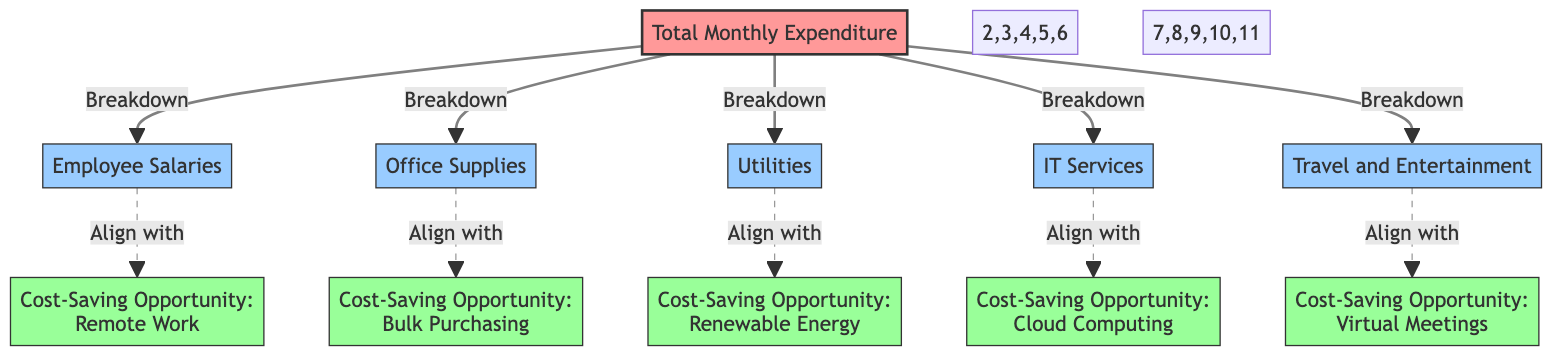What is the total node count in the diagram? The diagram has 11 nodes, including the total monthly expenditure node and the six categories of expenditure along with five cost-saving opportunities.
Answer: 11 How many cost-saving opportunities are listed in the diagram? There are five cost-saving opportunities shown in the diagram, which are represented by the nodes connected to the category nodes.
Answer: 5 Which category is aligned with remote work as a cost-saving opportunity? The Employee Salaries category is linked to the Remote Work cost-saving opportunity, indicating a focus on reducing salary costs through this method.
Answer: Employee Salaries What type of lines connect the categories to their cost-saving opportunities? The categories are connected to their respective cost-saving opportunities with dashed lines, which typically indicate a non-direct or potential relationship.
Answer: Dashed lines Which categories are associated with cost-saving opportunities related to bulk purchasing and cloud computing? The Office Supplies category is associated with Bulk Purchasing, while the IT Services category aligns with Cloud Computing.
Answer: Office Supplies, IT Services What is the relationship between utilities and renewable energy? Utilities is connected to Renewable Energy through a dashed line, indicating that there is a potential cost-saving opportunity in utilizing renewable energy sources for utility costs.
Answer: Align with How many distinct categories contribute to monthly expenditure? The diagram displays six distinct categories that together constitute the total monthly expenditure.
Answer: 6 Which cost-saving opportunity aligns with Travel and Entertainment? The diagram indicates that the Travel and Entertainment category aligns with Virtual Meetings as a cost-saving opportunity.
Answer: Virtual Meetings In which context is a cost-saving opportunity represented by the cloud computing node? Cloud Computing is represented as a cost-saving opportunity in relation to IT Services, suggesting potential cost reductions in that area through the use of cloud solutions.
Answer: IT Services 